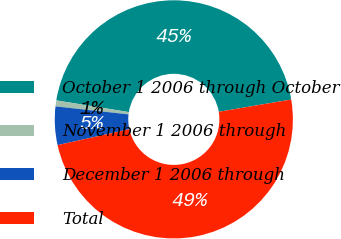<chart> <loc_0><loc_0><loc_500><loc_500><pie_chart><fcel>October 1 2006 through October<fcel>November 1 2006 through<fcel>December 1 2006 through<fcel>Total<nl><fcel>44.79%<fcel>0.81%<fcel>5.21%<fcel>49.19%<nl></chart> 